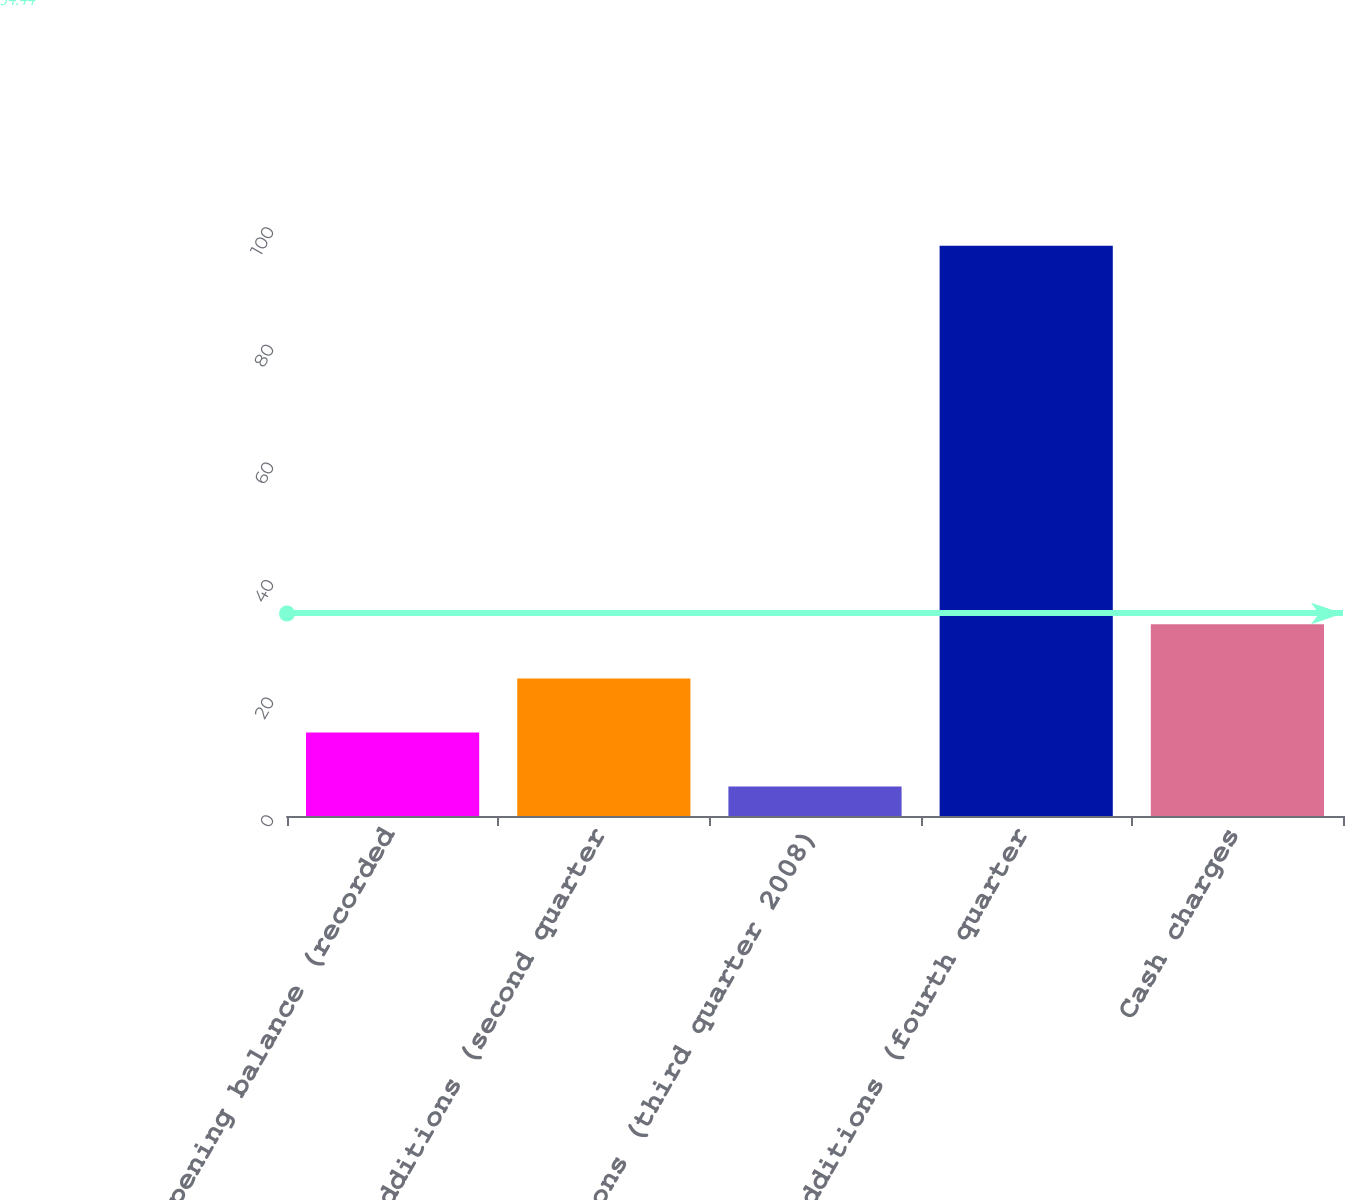Convert chart to OTSL. <chart><loc_0><loc_0><loc_500><loc_500><bar_chart><fcel>Opening balance (recorded<fcel>Additions (second quarter<fcel>Additions (third quarter 2008)<fcel>Additions (fourth quarter<fcel>Cash charges<nl><fcel>14.2<fcel>23.4<fcel>5<fcel>97<fcel>32.6<nl></chart> 